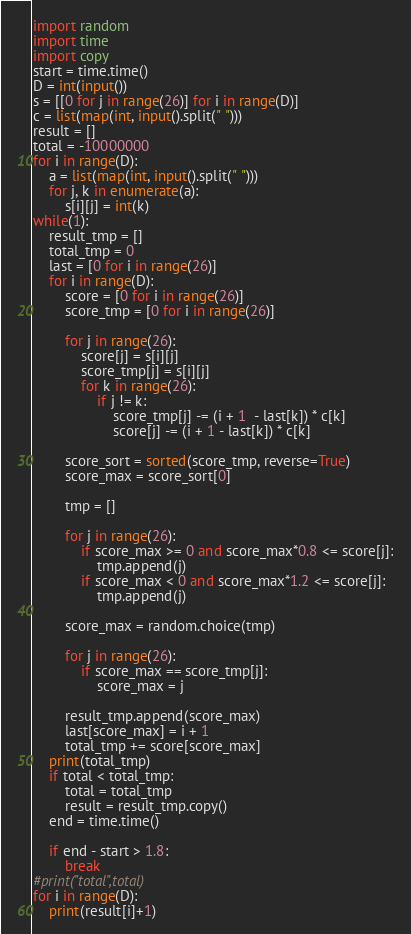Convert code to text. <code><loc_0><loc_0><loc_500><loc_500><_Python_>import random
import time
import copy
start = time.time()
D = int(input())
s = [[0 for j in range(26)] for i in range(D)]
c = list(map(int, input().split(" ")))
result = []
total = -10000000
for i in range(D):
    a = list(map(int, input().split(" ")))
    for j, k in enumerate(a):
        s[i][j] = int(k)
while(1):
    result_tmp = []
    total_tmp = 0
    last = [0 for i in range(26)]
    for i in range(D):
        score = [0 for i in range(26)]
        score_tmp = [0 for i in range(26)]

        for j in range(26):
            score[j] = s[i][j]
            score_tmp[j] = s[i][j]
            for k in range(26):
                if j != k:
                    score_tmp[j] -= (i + 1  - last[k]) * c[k] 
                    score[j] -= (i + 1 - last[k]) * c[k]

        score_sort = sorted(score_tmp, reverse=True)
        score_max = score_sort[0]

        tmp = []
        
        for j in range(26):
            if score_max >= 0 and score_max*0.8 <= score[j]:
                tmp.append(j)
            if score_max < 0 and score_max*1.2 <= score[j]:
                tmp.append(j)

        score_max = random.choice(tmp)
        
        for j in range(26):
            if score_max == score_tmp[j]:
                score_max = j

        result_tmp.append(score_max)
        last[score_max] = i + 1
        total_tmp += score[score_max]
    print(total_tmp)
    if total < total_tmp:
        total = total_tmp
        result = result_tmp.copy()
    end = time.time()
    
    if end - start > 1.8:
        break
#print("total",total)
for i in range(D):
    print(result[i]+1)</code> 